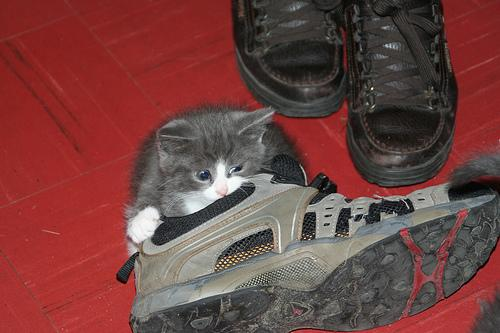What is the color of the floor under the cat and what type of floor is it? The floor under the cat is red and it is a laminated floor. What type of animal is prominently featured in the image and what is the unique feature of their appearance? A small grey and white kitten with blue eyes is prominently featured in the image. How many eyes are visible on the kitten and what is the color of those eyes? Two eyes are visible on the kitten and they are blue. Count the number of design elements mentioned on the tennis shoe and list them. There are five design elements mentioned: red designs on the sole, black mesh, red symbol on the bottom, black laces, and black tongue. Can you provide a brief description of the scene captured in the image? A grey and white kitten is sitting on a red laminated floor, chewing on a tennis shoe that has red designs on the sole. Briefly explain the object interaction happening between the kitten and the tennis shoe in the image. The kitten is chewing on the tennis shoe, which has red designs on its sole. Based on the image, determine if the kitten is indoors or outdoors and justify your answer. The kitten is indoors as it is sitting on a red laminated floor, typically found inside a home or building. Describe the sentiment or emotion conveyed by the image. The image conveys a playful and curious emotion, with the kitten engaging with the tennis shoe. Mention the color of the kitten's nose and ears in the image. The kitten has a pink nose, grey left ear, and grey right ear. How many shoes can be seen in the image and what are their characteristics? There are two brown shoes on the red floor, one has a red symbol on the bottom, and the other is a grey tennis shoe with black mesh. Explain the anomaly of having a grey and white kitten in a shoe. Unusual or not expected interaction between the kitten and shoe. Rate the quality of the image with the kitten and the shoe, from 1 to 10 (10 being the best). 9, as the image provides clear details on the kitten and shoe. Does the grey tennis shoe have any red designs on the sole? Yes, the tennis shoe has red designs on the sole. In the image, what color are the boots? The boots are brown. What is the primary color of the floor under the cat? Red Describe the shoe that has a red x on the bottom. Grey tennis shoe with red designs and black mesh Are there any words or symbols visible in the image? No words or symbols are visible. Look for a small houseplant next to the cat and describe the shape of its leaves. Do the leaves have a unique texture or pattern? The provided object information does not contain any reference to a houseplant or leaves. Users will be misguided as they try to find an object that doesn't exist within the image. Is there a striped orange-and-black umbrella in the background? Look carefully at its pattern and size. All objects described in the image give information about the cat, shoes, and the floor, but there is no mention of an umbrella. This instruction will mislead users by asking them to find an object that doesn't exist in the image. Does the grey and white kitten have a collar? No, the kitten does not have a collar. What can you infer from the image regarding the cat's relationship with the shoe it interacts with? The cat plays and chews on the tennis shoe. Identify the emotions that the kitten might be experiencing in the image. Curious, playful Point out the spotted brown dog sitting next to the gray and white cat. Observe the dog's expression and posture. The objects in the image only refer to a cat and some shoes. There is no mention of any dog, so the instruction will lead users to search for something that doesn't exist. Describe the kitten in the image. Grey and white kitten with blue eyes, chewing on a tennis shoe Identify any strange occurrences in the image. Kitten chewing on a shoe Is the image of high quality for the given information about the objects? Yes, the image has high-quality details on the objects. How many cats are shown in the image? Only one cat is shown. Describe the location of the cat's left ear in the image. Grey left ear, X:235 Y:105 Width:41 Height:41 Discover the pile of colorful children's books in the corner of the image. What do you think the titles of these books might be? None of the objects listed in the image refer to any books, let alone a pile of colorful children's books. This instruction will confuse users as they will try to locate an object that is not present in the image. Describe the shoe that the kitten is interacting with. Grey tennis shoe with red designs on the sole Identify the red bird perched on top of the grey tennis shoe. Pay attention to its vibrant feathers and its beak. The objects described in the image do not include any birds. This instruction will be misleading as it asks users to look for a non-existent object. Is the kitten near a shoe in the image? Yes, the kitten is near a shoe. Can you find the green ball in the image? Make sure to notice the details on its surface. No, it's not mentioned in the image. 